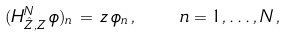Convert formula to latex. <formula><loc_0><loc_0><loc_500><loc_500>( H ^ { N } _ { \hat { Z } , { Z } } \, \phi ) _ { n } \, = \, z \, \phi _ { n } \, , \quad n = 1 , \dots , N \, ,</formula> 